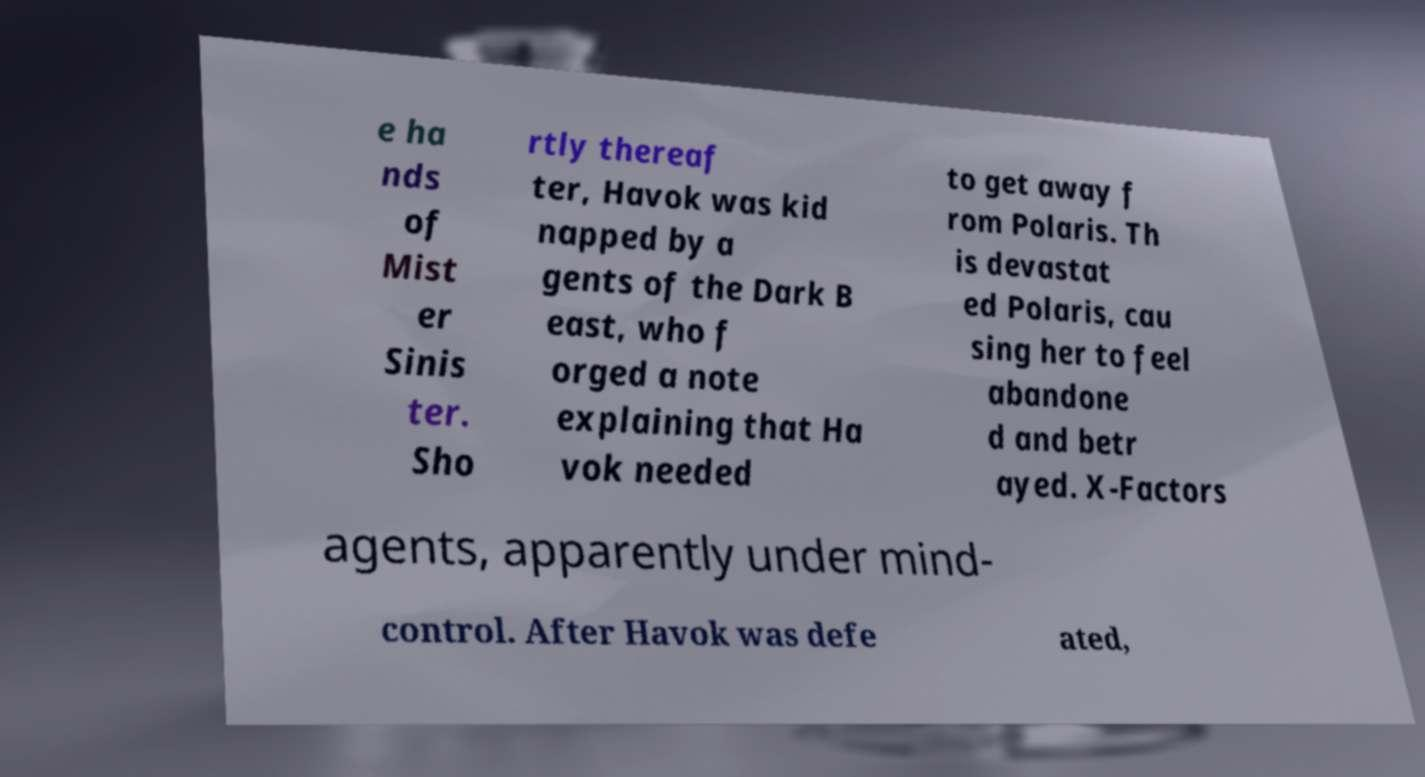Can you read and provide the text displayed in the image?This photo seems to have some interesting text. Can you extract and type it out for me? e ha nds of Mist er Sinis ter. Sho rtly thereaf ter, Havok was kid napped by a gents of the Dark B east, who f orged a note explaining that Ha vok needed to get away f rom Polaris. Th is devastat ed Polaris, cau sing her to feel abandone d and betr ayed. X-Factors agents, apparently under mind- control. After Havok was defe ated, 